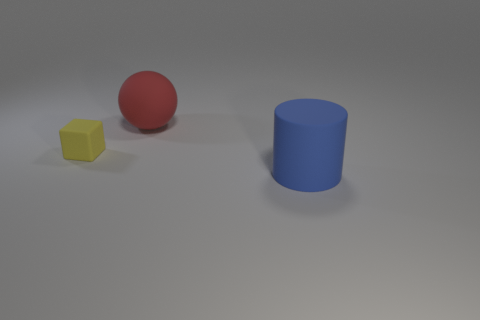Are there any other things that are the same shape as the small yellow rubber object?
Your response must be concise. No. Are there any other things that have the same size as the matte cube?
Offer a terse response. No. How many objects are matte objects that are in front of the rubber ball or things to the left of the cylinder?
Offer a terse response. 3. What number of red things are rubber things or cylinders?
Provide a succinct answer. 1. Is the yellow thing made of the same material as the sphere?
Provide a succinct answer. Yes. How many other blue objects have the same size as the blue matte thing?
Your answer should be compact. 0. Is the number of cylinders behind the big sphere the same as the number of spheres?
Offer a terse response. No. How many matte objects are in front of the red rubber object and behind the big rubber cylinder?
Offer a very short reply. 1. There is a red object that is the same size as the blue matte thing; what material is it?
Provide a succinct answer. Rubber. Are there an equal number of red things that are right of the large cylinder and rubber things that are on the left side of the ball?
Make the answer very short. No. 